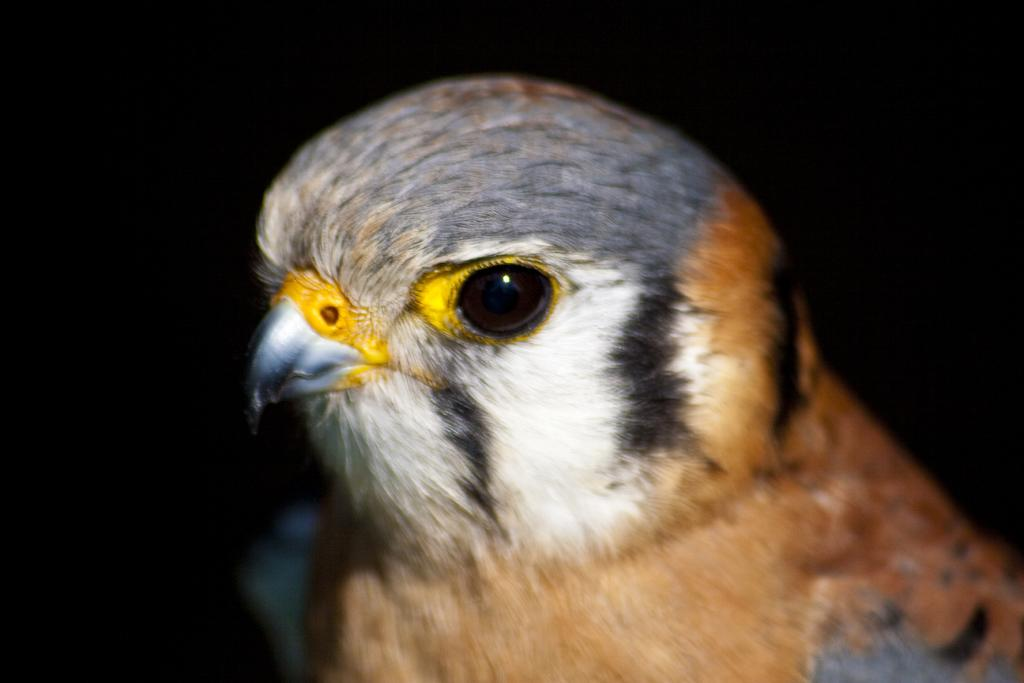What type of animal is present in the image? There is a bird in the image. Can you describe the perspective of the image? The image is a zoomed-in view of the bird. How many toys can be seen floating around the jellyfish in the image? There are no toys or jellyfish present in the image; it features a bird. 